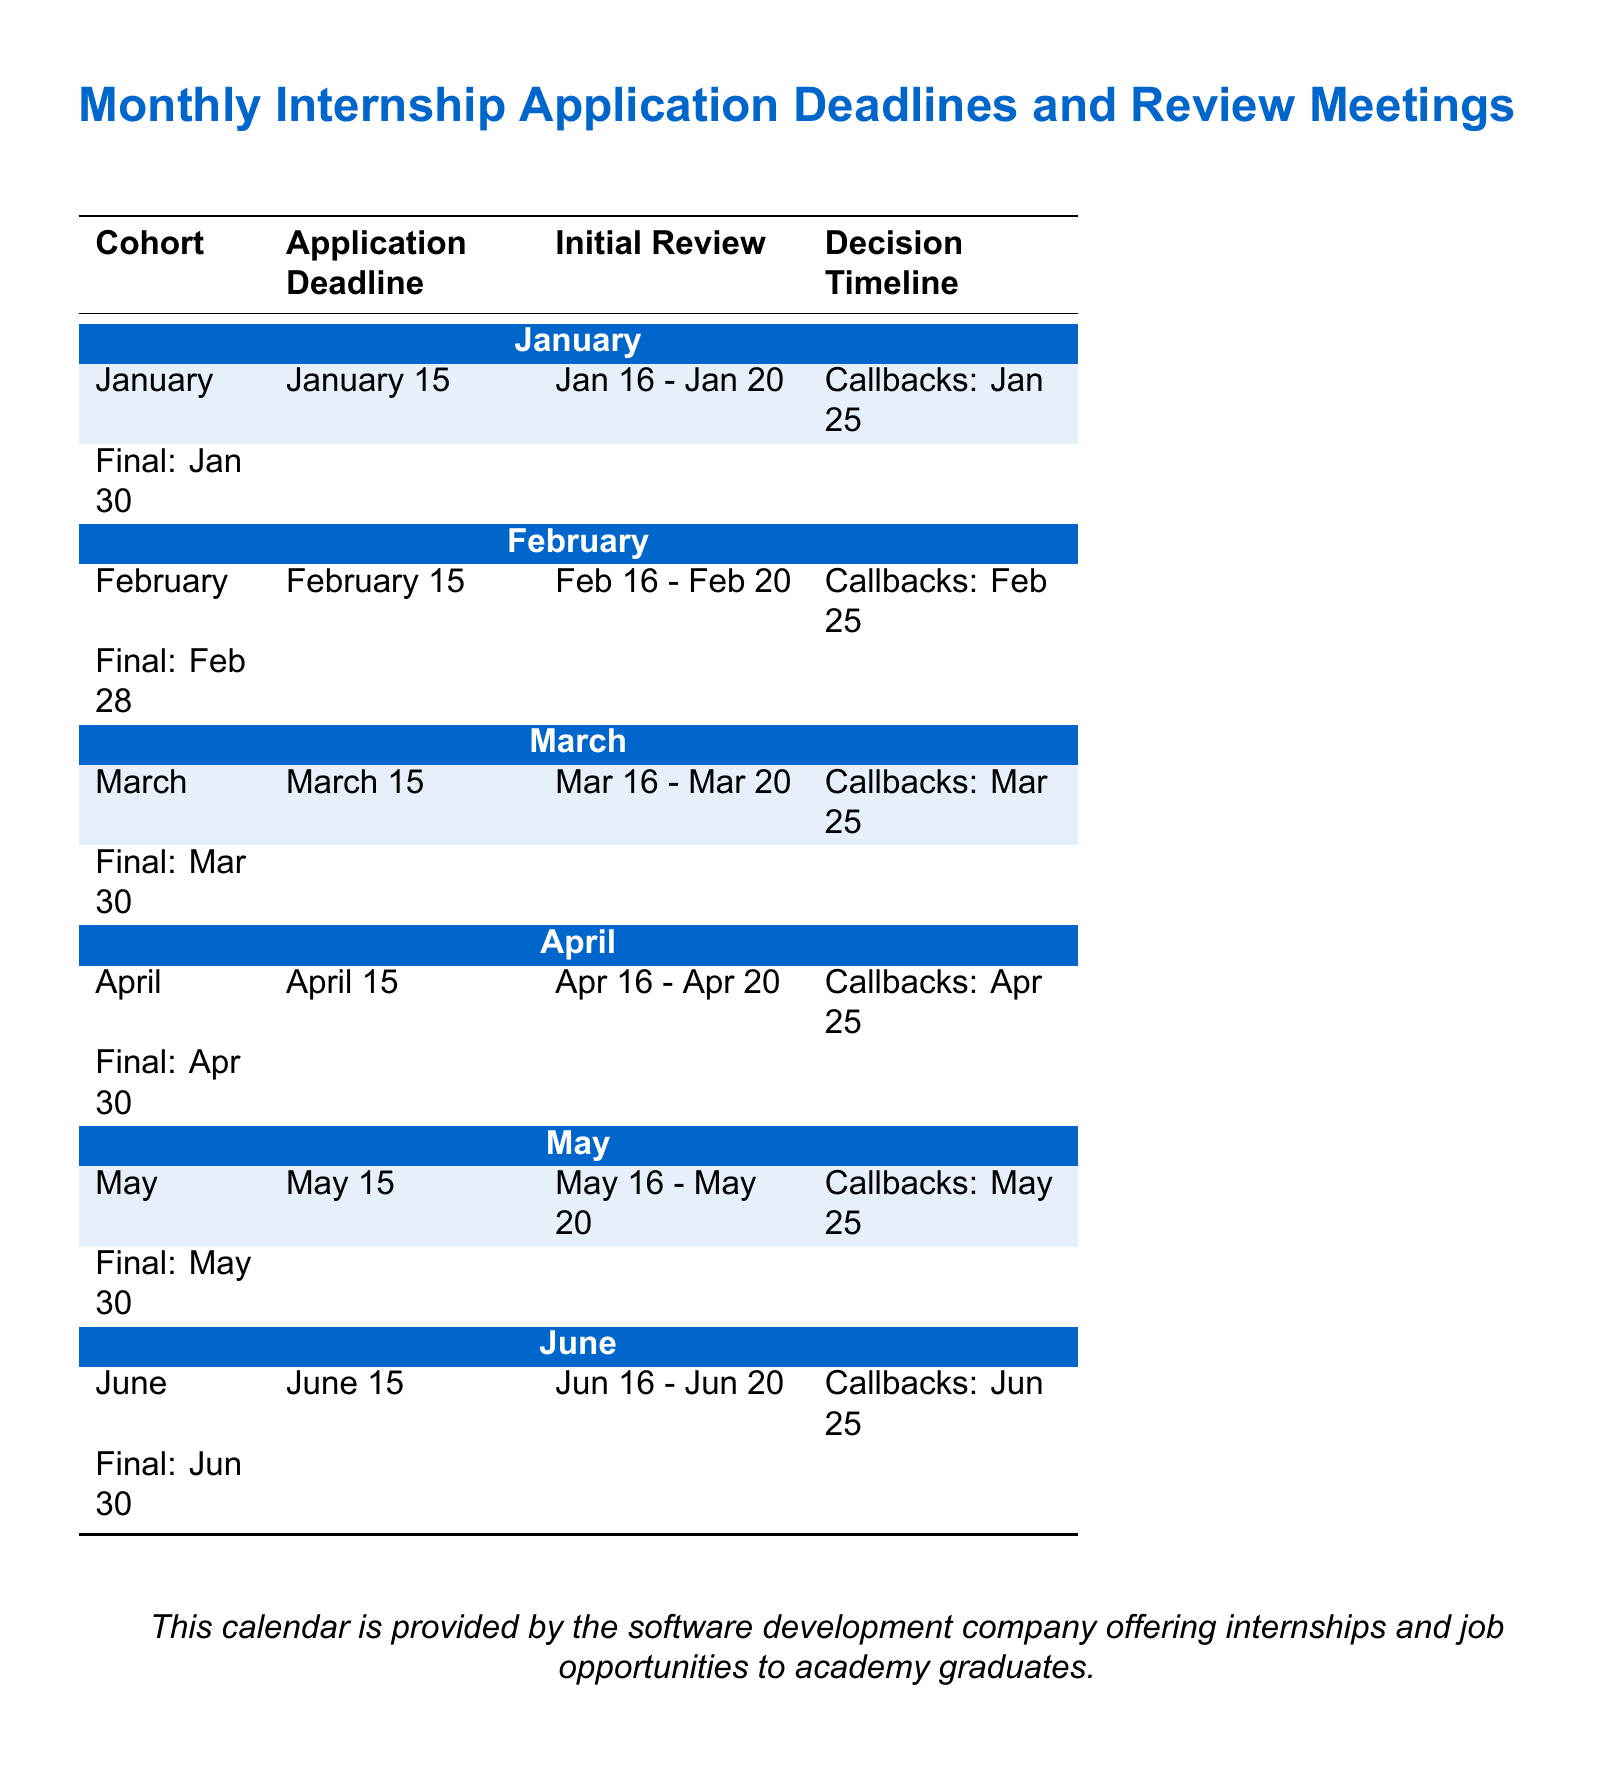What is the application deadline for January? The application deadline for January is listed in the document specifically under the "Application Deadline" column for the January cohort.
Answer: January 15 When does the initial review for the March cohort take place? The document indicates the dates for the initial review for March under the corresponding column.
Answer: March 16 - March 20 What is the decision final date for the April cohort? The final decision date for the April cohort is found in the "Decision Timeline" section related to April.
Answer: April 30 How many days does the review process last for the June cohort? To find this, one needs to calculate the duration from the initial review dates mentioned for June.
Answer: 5 days Which cohort has the earliest application deadline? The earliest application deadline can be identified by comparing all cohorts listed in the document.
Answer: January What are the callback dates for the February cohort? The callback dates are found in the "Decision Timeline" section for February.
Answer: February 25 How many months are covered in the internship calendar? The document lists the cohorts from January to June, which indicates the number of months addressed.
Answer: 6 months What color is used for the header of the January cohort? The header color for January is indicated in the formatting section of the calendar.
Answer: RGB(0,102,204) 